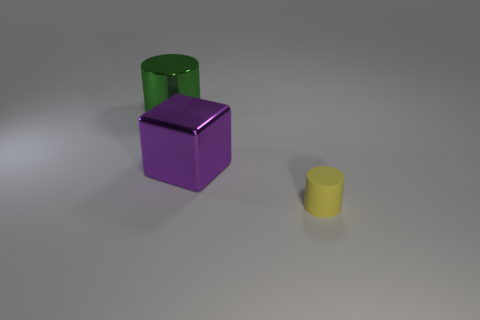Is there any other thing that is the same size as the rubber cylinder?
Ensure brevity in your answer.  No. What is the color of the metal thing to the left of the metal object that is in front of the cylinder behind the yellow rubber cylinder?
Make the answer very short. Green. How many other objects are there of the same size as the purple cube?
Offer a very short reply. 1. Is there anything else that is the same shape as the big purple object?
Keep it short and to the point. No. What is the color of the other large object that is the same shape as the yellow thing?
Keep it short and to the point. Green. There is another big object that is the same material as the purple object; what is its color?
Provide a short and direct response. Green. Are there an equal number of small yellow things behind the small yellow rubber object and brown balls?
Provide a succinct answer. Yes. Is the size of the metal object left of the purple object the same as the small yellow object?
Your answer should be very brief. No. What color is the cube that is the same size as the green cylinder?
Your answer should be compact. Purple. There is a metallic thing in front of the object that is behind the big cube; are there any matte cylinders behind it?
Offer a very short reply. No. 